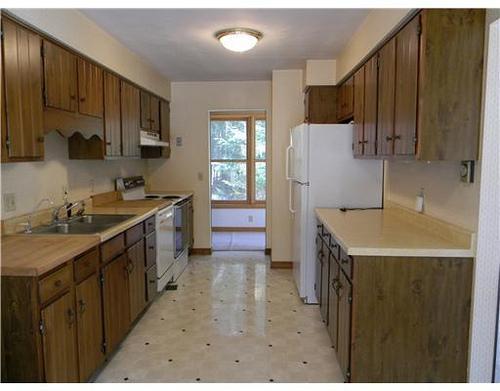How many lights are in the room?
Give a very brief answer. 1. 